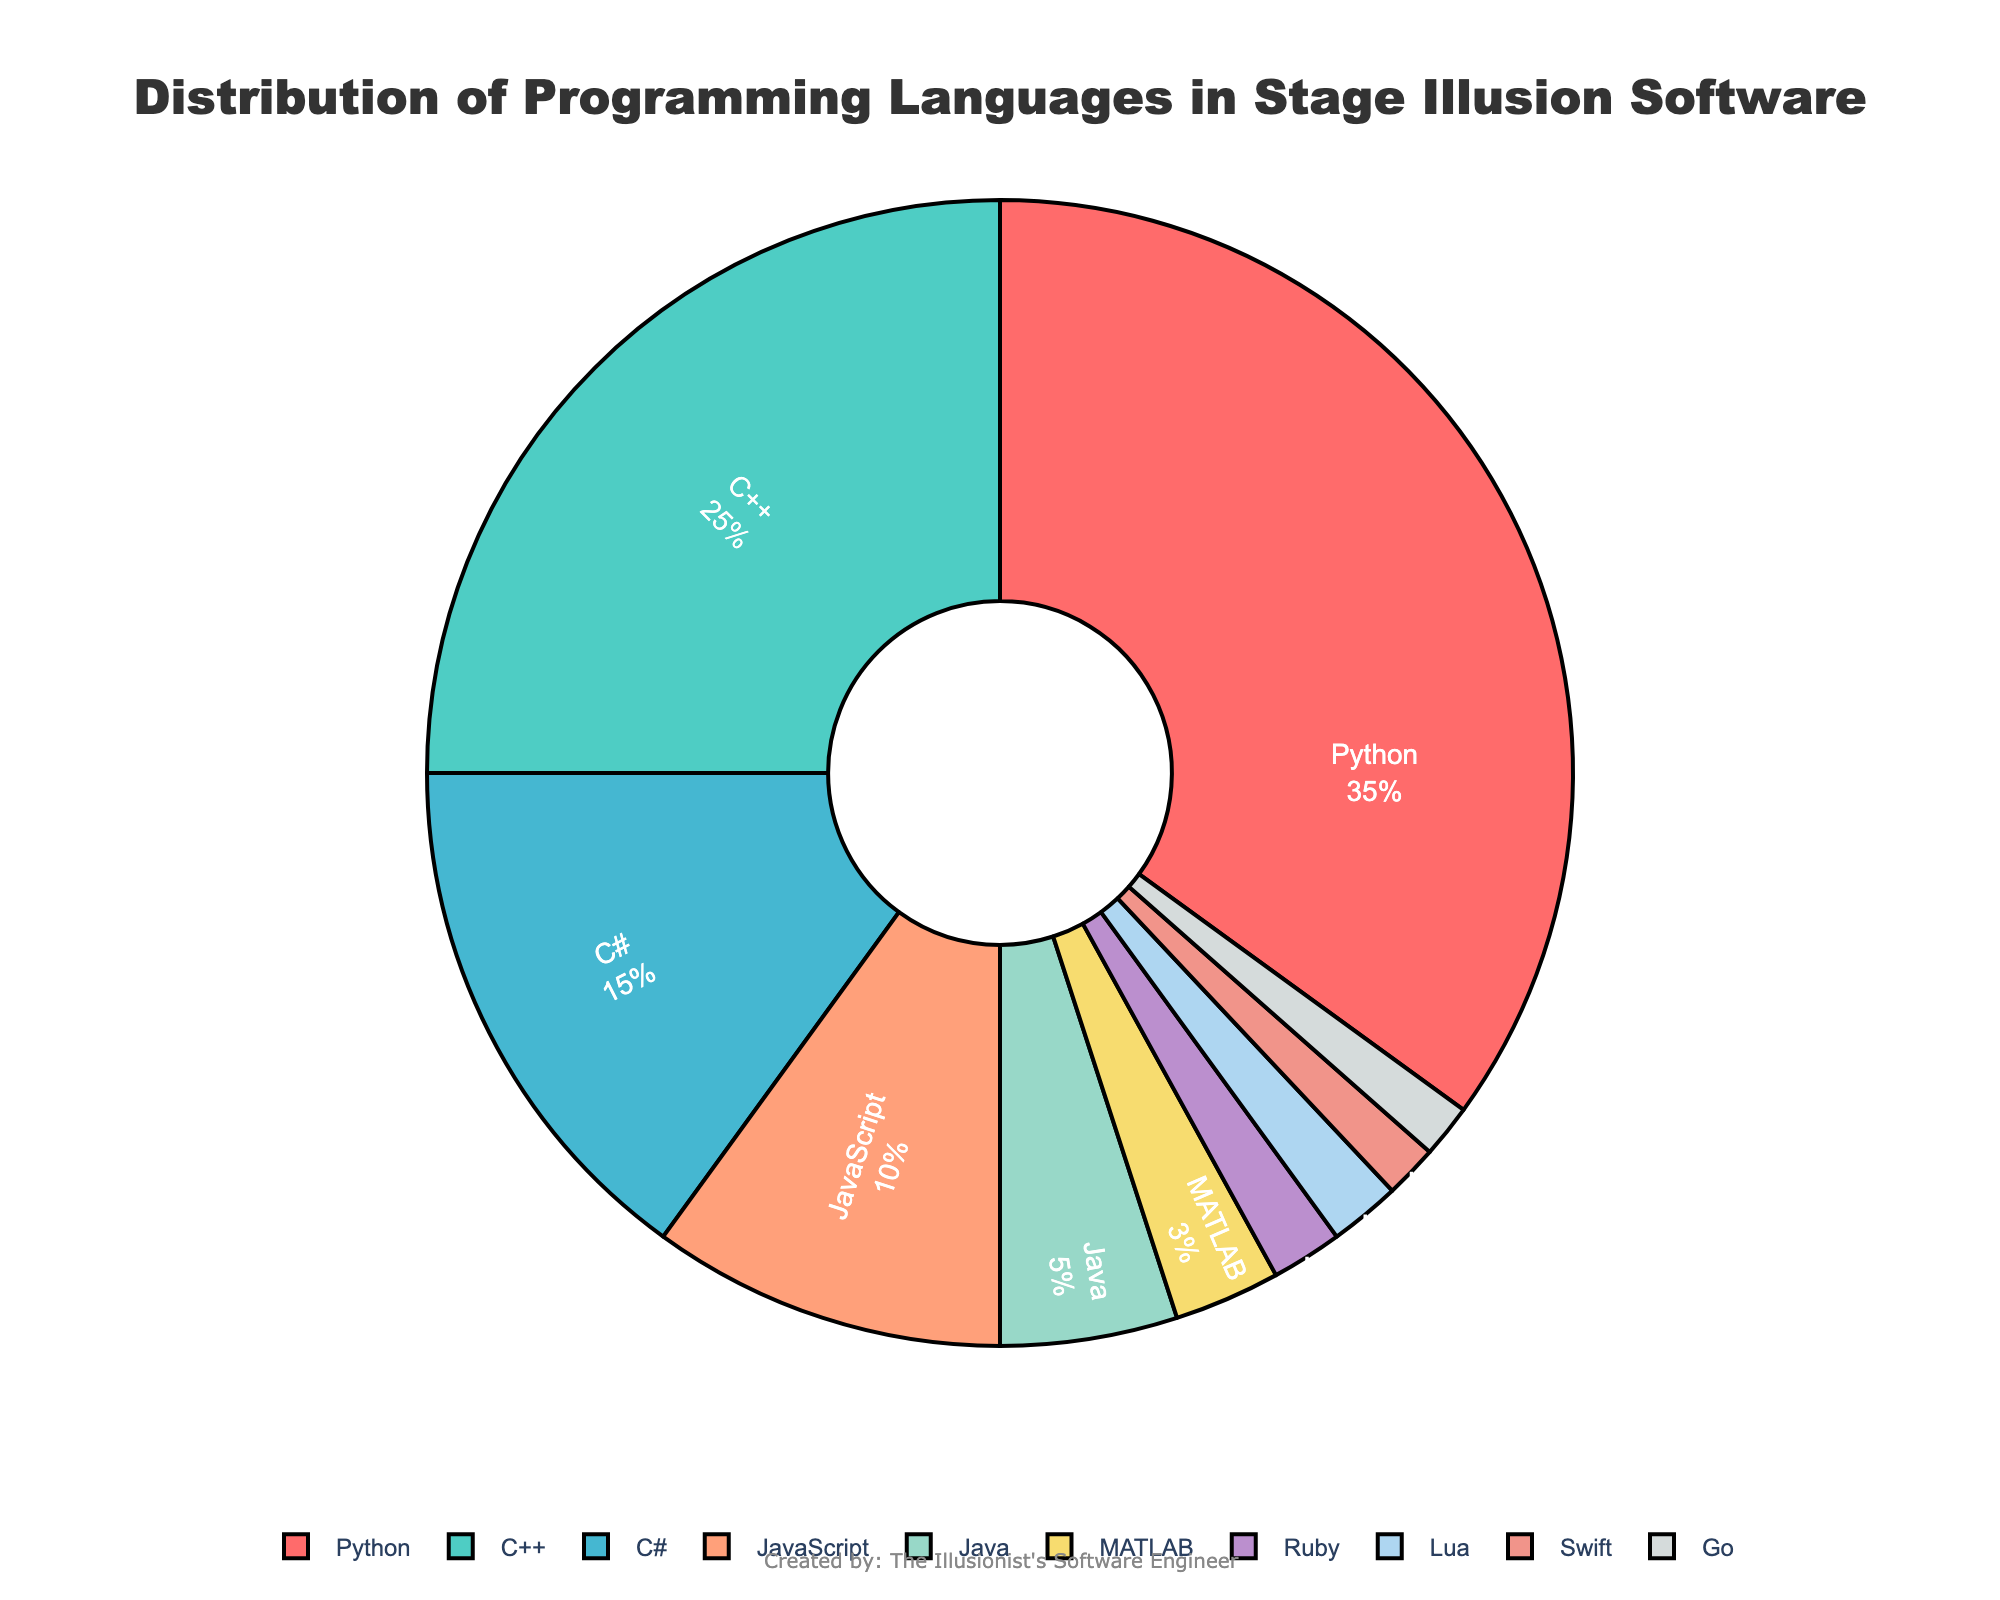What percentage of the programming languages is comprised of Python and JavaScript together? To find the combined percentage of Python and JavaScript, sum their individual percentages: Python is 35% and JavaScript is 10%. The combined percentage is 35% + 10% = 45%.
Answer: 45% Which language has the smallest share in the distribution? By referring to the pie chart, the language with the smallest share, in terms of percentage, is Swift (1.5%) and Go (1.5%). These are the smallest slices.
Answer: Swift and Go Is the percentage of C# greater than the sum of Ruby and Lua? The percentage of C# is 15%. The combined percentage of Ruby and Lua is 2% + 2% = 4%. Since 15% is greater than 4%, the percentage of C# is indeed greater.
Answer: Yes Which programming language has the second largest share? The second-largest share, after Python (35%), is held by C++ with 25%. This can be determined by comparing the slices of the pie chart.
Answer: C++ What is the combined percentage of the least used three languages? The least used languages are Swift (1.5%), Go (1.5%), and Lua (2%). Adding these, the combined percentage is 1.5% + 1.5% + 2% = 5%.
Answer: 5% By how much does the share of Python exceed the share of C++? Python's share is 35%, and C++'s share is 25%. The difference is 35% - 25% = 10%.
Answer: 10% Are there more languages contributing less than 5% or more than 10% each? There are five languages contributing less than 5% each (Java, MATLAB, Ruby, Lua, Swift, and Go), and three languages contributing more than 10% each (Python, C++, and C#). There are more languages contributing less than 5%.
Answer: Less than 5% What is the percentage difference between the shares of C# and JavaScript? The percentage share of C# is 15% and JavaScript is 10%. The difference between them is 15% - 10% = 5%.
Answer: 5% What color represents MATLAB in the pie chart? MATLAB is visually represented by a yellow-ish color (based on the order of the slices and the provided color palette).
Answer: Yellow 